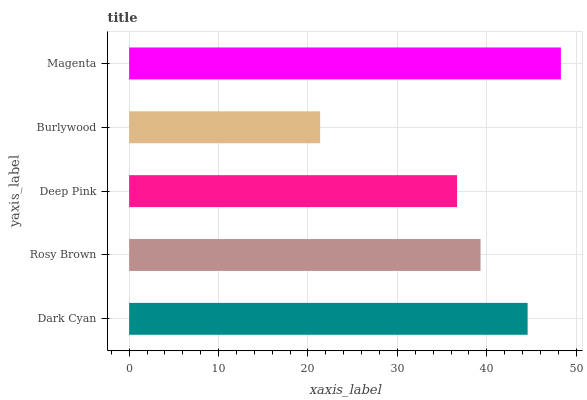Is Burlywood the minimum?
Answer yes or no. Yes. Is Magenta the maximum?
Answer yes or no. Yes. Is Rosy Brown the minimum?
Answer yes or no. No. Is Rosy Brown the maximum?
Answer yes or no. No. Is Dark Cyan greater than Rosy Brown?
Answer yes or no. Yes. Is Rosy Brown less than Dark Cyan?
Answer yes or no. Yes. Is Rosy Brown greater than Dark Cyan?
Answer yes or no. No. Is Dark Cyan less than Rosy Brown?
Answer yes or no. No. Is Rosy Brown the high median?
Answer yes or no. Yes. Is Rosy Brown the low median?
Answer yes or no. Yes. Is Deep Pink the high median?
Answer yes or no. No. Is Dark Cyan the low median?
Answer yes or no. No. 